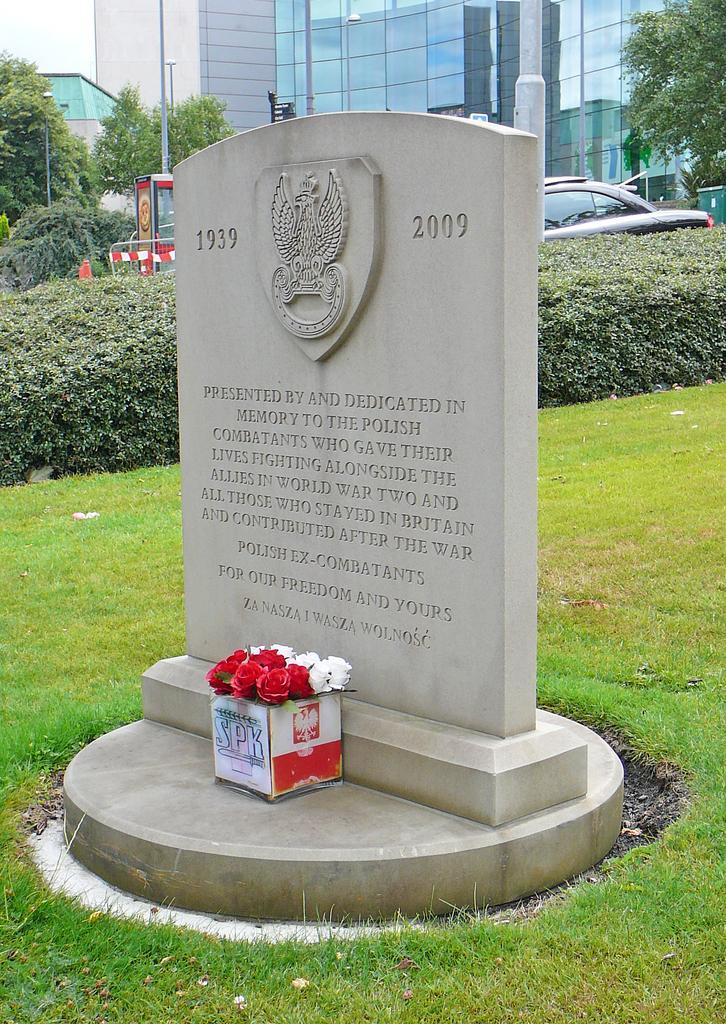Could you give a brief overview of what you see in this image? In this image I can see an open grass ground and in the front I can see a tombstone. I can also see few flowers in the front. In the background I an see few trees, a car, few poles and few buildings. I can also see an orange colour thing in the background. 